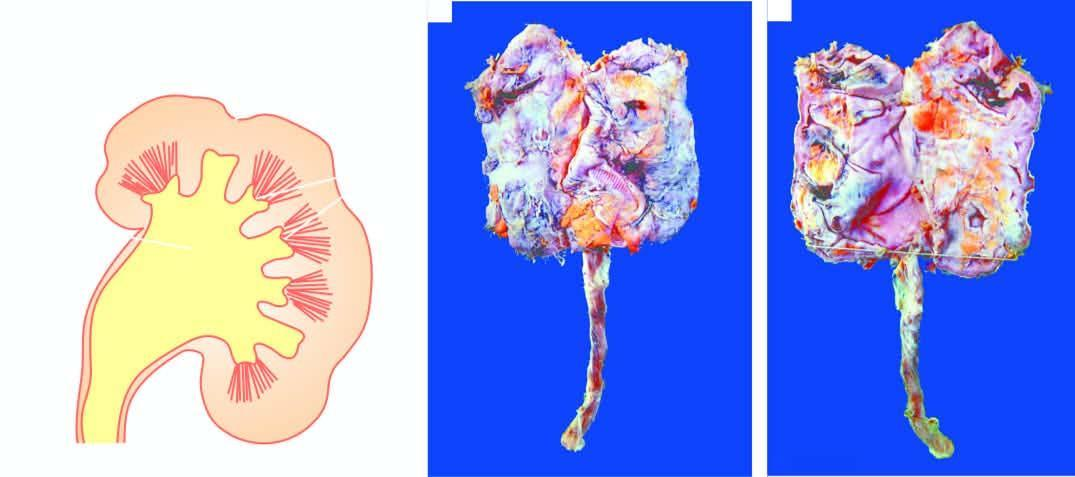what is small contracted kidney in chronic pyelonephritis with?
Answer the question using a single word or phrase. Calyectasis 